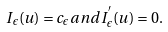<formula> <loc_0><loc_0><loc_500><loc_500>I _ { \epsilon } ( u ) = c _ { \epsilon } a n d I ^ { ^ { \prime } } _ { \epsilon } ( u ) = 0 .</formula> 